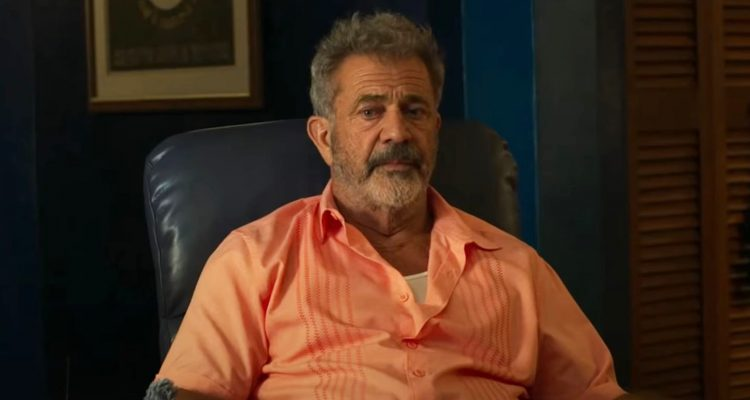Can you provide a backstory for the character in the image? Certainly! The character in the image could be named John, a retired professor who spent decades teaching literature at a prestigious university. After retiring, he moved to a quieter town where he spends his days reading, mentoring young aspiring writers, and reflecting on his life’s work. The blue leather chair is his favorite spot where he dives into deep thought and reminisces about the impactful moments of his career. The framed certificate on the wall is an award he received for his significant contributions to the field of literature, a constant reminder of his dedication and passion. What could John be thinking about in this moment? John could be contemplating a philosophical question that has always intrigued him. Perhaps he is reflecting on the meaning of success and how it has evolved over the years both for him personally and for society at large. He might also be thinking about a manuscript he recently received from a young writer, pondering over its potential and deciding how best to guide the author in enhancing their work. 